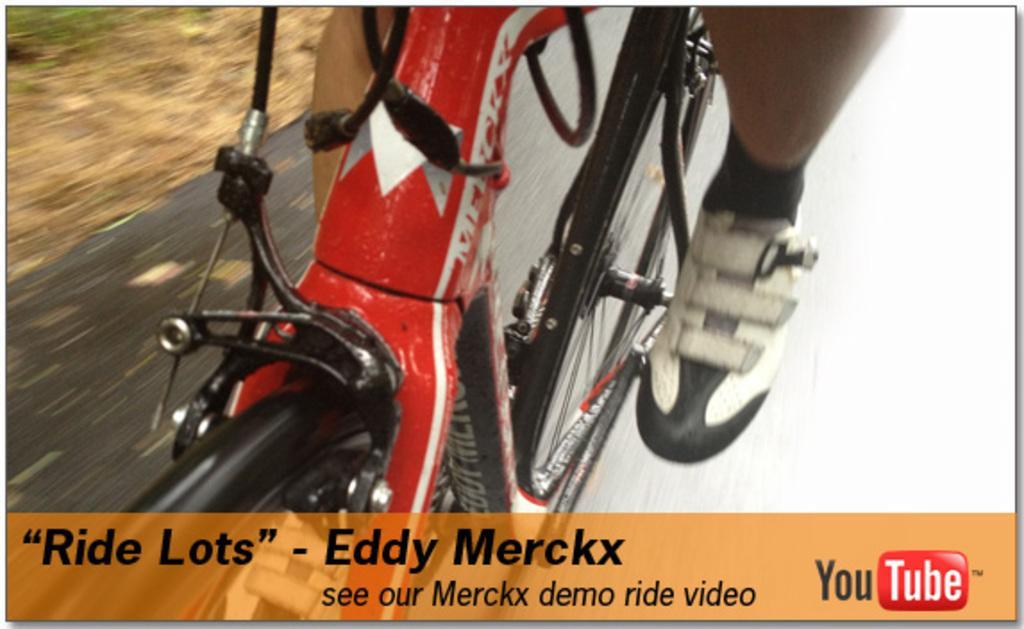Describe this image in one or two sentences. It is an edited image and there is a cycle and only two wheels and pedal of the cycle are visible in the image and there are two legs of some person riding the cycle and below the picture there is some quotation. 